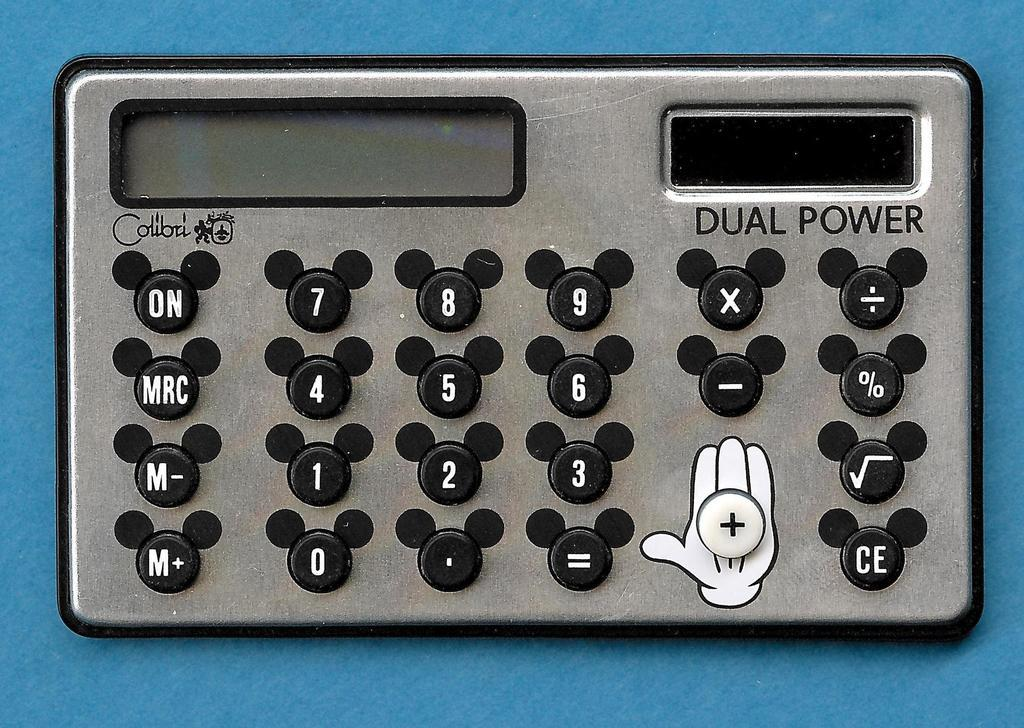What type of object can be seen in the image? There is an electronic gadget in the image. What is the rate of lumber production in the image? There is no mention of lumber production or any related activities in the image, as it features an electronic gadget. 